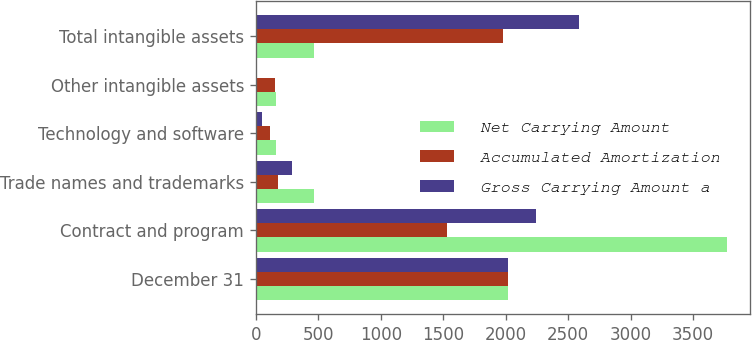Convert chart to OTSL. <chart><loc_0><loc_0><loc_500><loc_500><stacked_bar_chart><ecel><fcel>December 31<fcel>Contract and program<fcel>Trade names and trademarks<fcel>Technology and software<fcel>Other intangible assets<fcel>Total intangible assets<nl><fcel>Net Carrying Amount<fcel>2018<fcel>3771<fcel>469<fcel>165<fcel>159<fcel>469<nl><fcel>Accumulated Amortization<fcel>2018<fcel>1531<fcel>177<fcel>116<fcel>155<fcel>1979<nl><fcel>Gross Carrying Amount a<fcel>2018<fcel>2240<fcel>292<fcel>49<fcel>4<fcel>2585<nl></chart> 